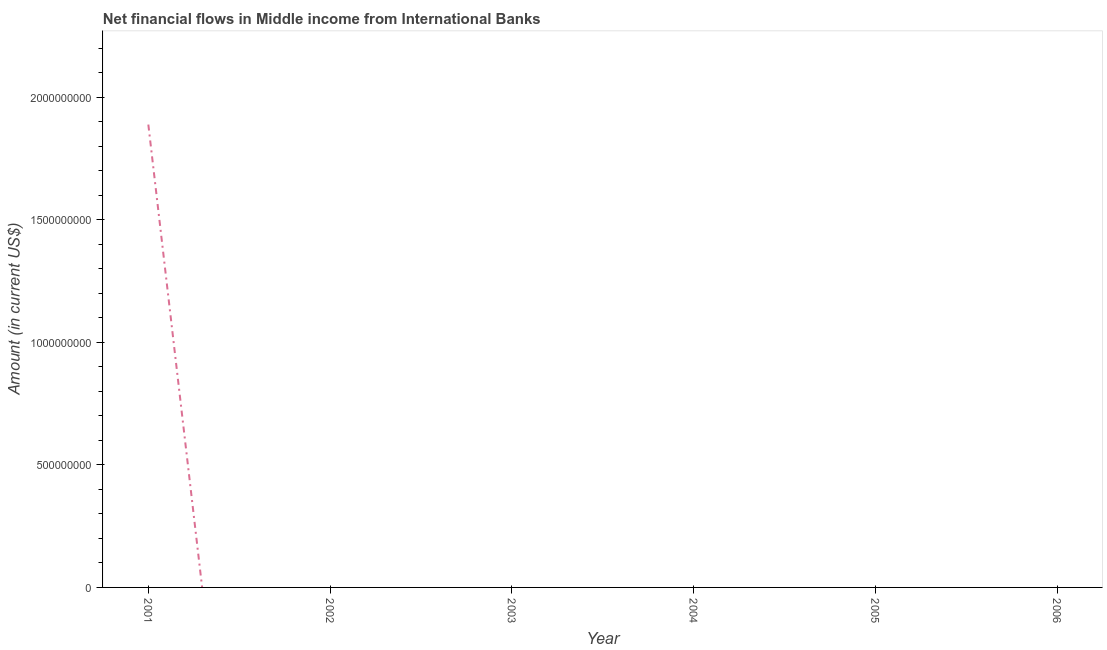Across all years, what is the maximum net financial flows from ibrd?
Ensure brevity in your answer.  1.89e+09. In which year was the net financial flows from ibrd maximum?
Your answer should be compact. 2001. What is the sum of the net financial flows from ibrd?
Keep it short and to the point. 1.89e+09. What is the average net financial flows from ibrd per year?
Keep it short and to the point. 3.15e+08. What is the median net financial flows from ibrd?
Ensure brevity in your answer.  0. What is the difference between the highest and the lowest net financial flows from ibrd?
Provide a succinct answer. 1.89e+09. Does the net financial flows from ibrd monotonically increase over the years?
Make the answer very short. No. What is the difference between two consecutive major ticks on the Y-axis?
Give a very brief answer. 5.00e+08. Does the graph contain any zero values?
Your response must be concise. Yes. What is the title of the graph?
Your answer should be compact. Net financial flows in Middle income from International Banks. What is the label or title of the Y-axis?
Ensure brevity in your answer.  Amount (in current US$). What is the Amount (in current US$) of 2001?
Provide a succinct answer. 1.89e+09. What is the Amount (in current US$) in 2002?
Keep it short and to the point. 0. What is the Amount (in current US$) of 2004?
Keep it short and to the point. 0. What is the Amount (in current US$) in 2005?
Offer a terse response. 0. What is the Amount (in current US$) in 2006?
Your answer should be compact. 0. 